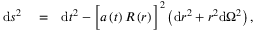Convert formula to latex. <formula><loc_0><loc_0><loc_500><loc_500>\begin{array} { r l r } { d s ^ { 2 } } & = } & { d t ^ { 2 } - \left [ a \left ( t \right ) R \left ( r \right ) \right ] ^ { 2 } \left ( d r ^ { 2 } + r ^ { 2 } d \Omega ^ { 2 } \right ) , } \end{array}</formula> 